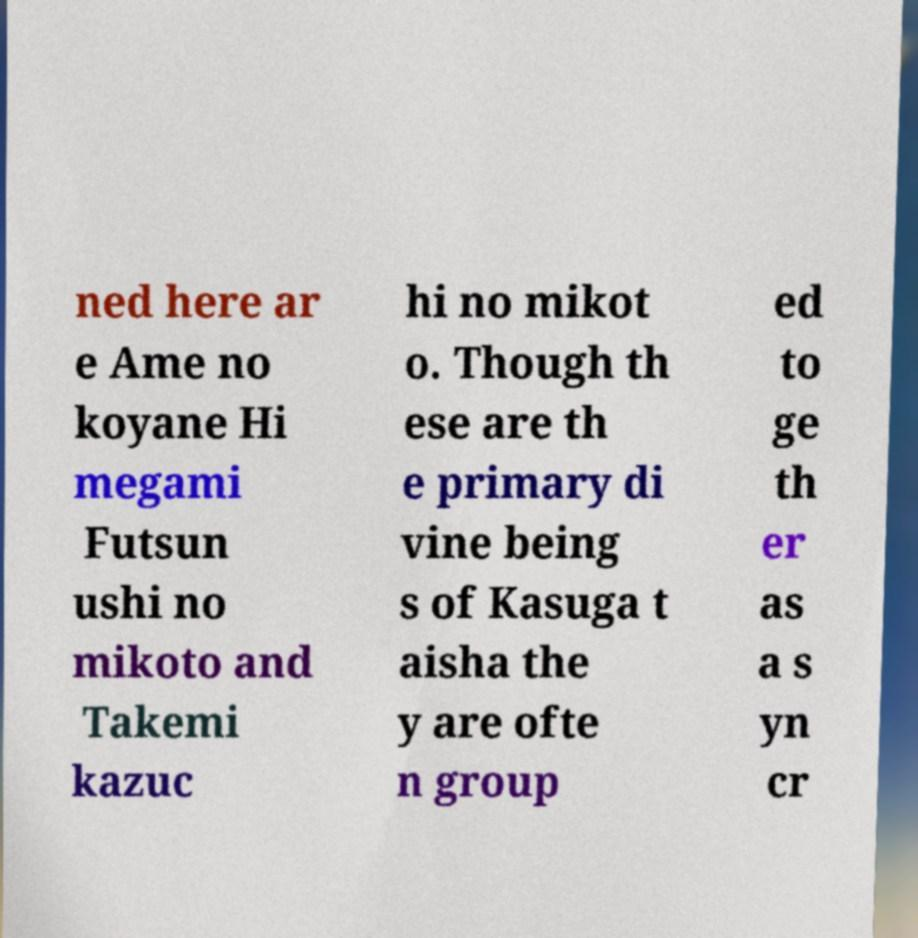There's text embedded in this image that I need extracted. Can you transcribe it verbatim? ned here ar e Ame no koyane Hi megami Futsun ushi no mikoto and Takemi kazuc hi no mikot o. Though th ese are th e primary di vine being s of Kasuga t aisha the y are ofte n group ed to ge th er as a s yn cr 